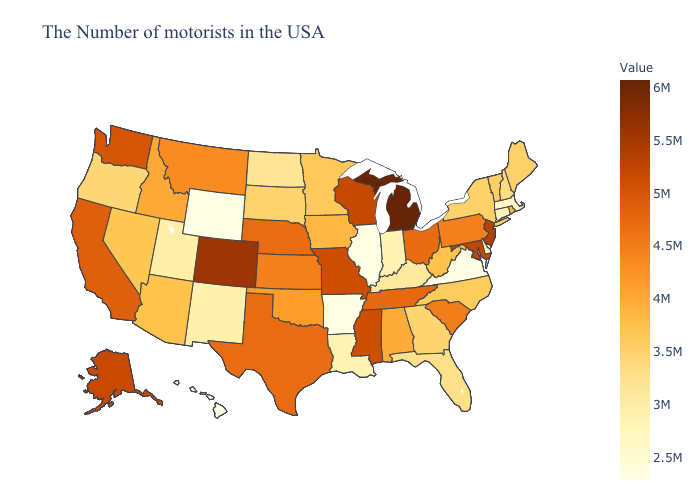Does Iowa have the highest value in the USA?
Short answer required. No. Among the states that border Wisconsin , does Iowa have the lowest value?
Be succinct. No. Which states have the lowest value in the MidWest?
Give a very brief answer. Illinois. Does Tennessee have the highest value in the South?
Keep it brief. No. Does New York have the lowest value in the USA?
Concise answer only. No. Among the states that border Maryland , which have the highest value?
Keep it brief. Pennsylvania. Among the states that border Nevada , which have the highest value?
Be succinct. California. 